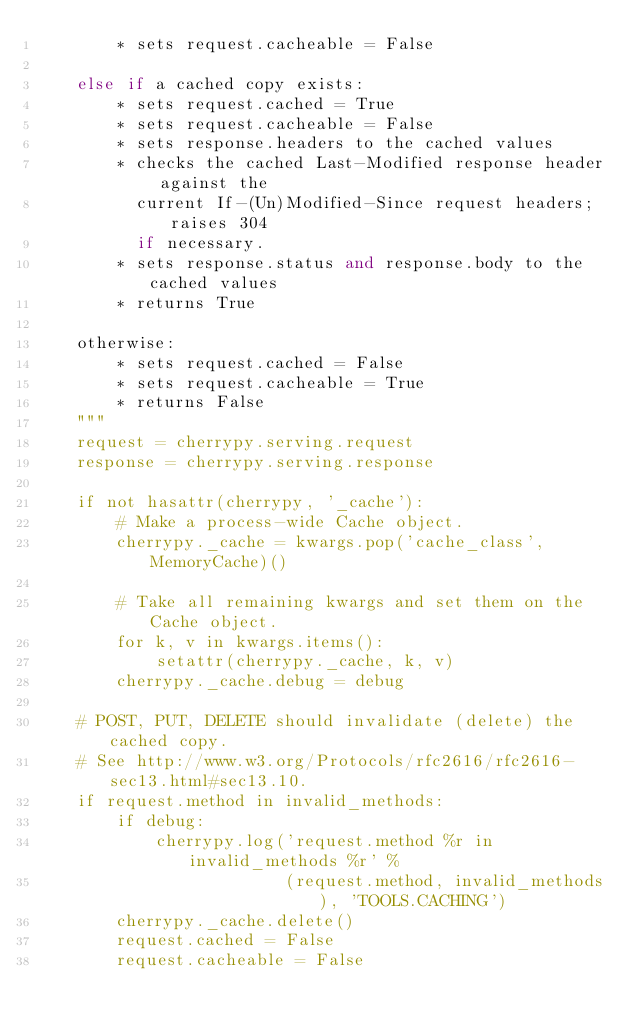<code> <loc_0><loc_0><loc_500><loc_500><_Python_>        * sets request.cacheable = False

    else if a cached copy exists:
        * sets request.cached = True
        * sets request.cacheable = False
        * sets response.headers to the cached values
        * checks the cached Last-Modified response header against the
          current If-(Un)Modified-Since request headers; raises 304
          if necessary.
        * sets response.status and response.body to the cached values
        * returns True

    otherwise:
        * sets request.cached = False
        * sets request.cacheable = True
        * returns False
    """
    request = cherrypy.serving.request
    response = cherrypy.serving.response

    if not hasattr(cherrypy, '_cache'):
        # Make a process-wide Cache object.
        cherrypy._cache = kwargs.pop('cache_class', MemoryCache)()

        # Take all remaining kwargs and set them on the Cache object.
        for k, v in kwargs.items():
            setattr(cherrypy._cache, k, v)
        cherrypy._cache.debug = debug

    # POST, PUT, DELETE should invalidate (delete) the cached copy.
    # See http://www.w3.org/Protocols/rfc2616/rfc2616-sec13.html#sec13.10.
    if request.method in invalid_methods:
        if debug:
            cherrypy.log('request.method %r in invalid_methods %r' %
                         (request.method, invalid_methods), 'TOOLS.CACHING')
        cherrypy._cache.delete()
        request.cached = False
        request.cacheable = False</code> 